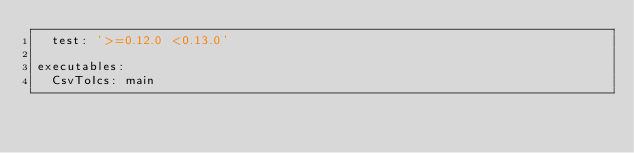<code> <loc_0><loc_0><loc_500><loc_500><_YAML_>  test: '>=0.12.0 <0.13.0'

executables:
  CsvToIcs: main
</code> 